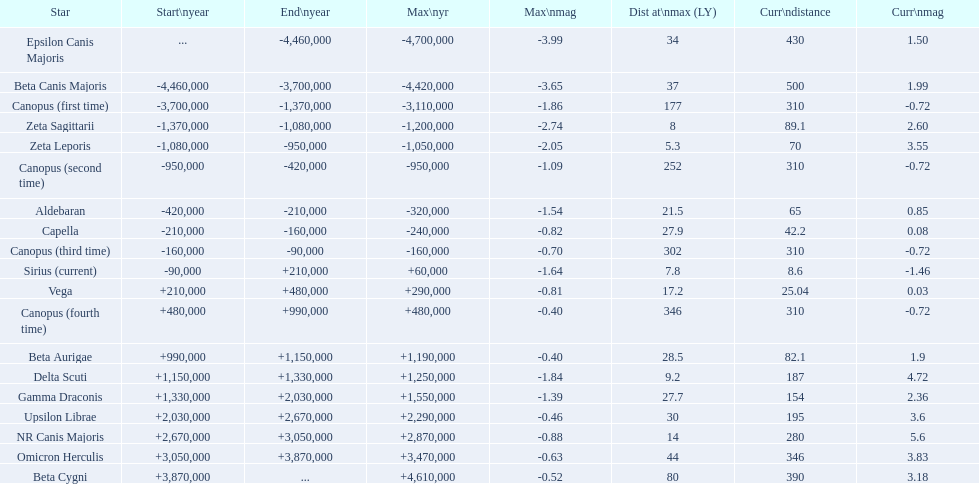What star has a a maximum magnitude of -0.63. Omicron Herculis. What star has a current distance of 390? Beta Cygni. 